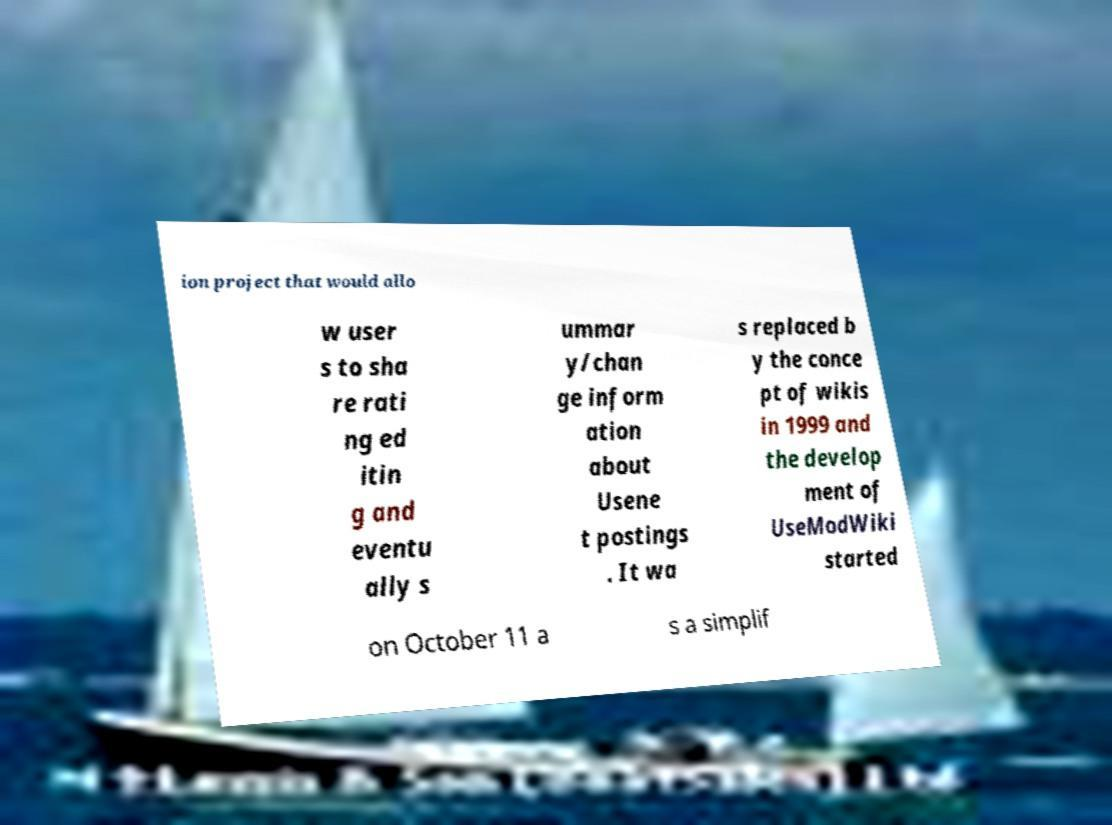Can you read and provide the text displayed in the image?This photo seems to have some interesting text. Can you extract and type it out for me? ion project that would allo w user s to sha re rati ng ed itin g and eventu ally s ummar y/chan ge inform ation about Usene t postings . It wa s replaced b y the conce pt of wikis in 1999 and the develop ment of UseModWiki started on October 11 a s a simplif 